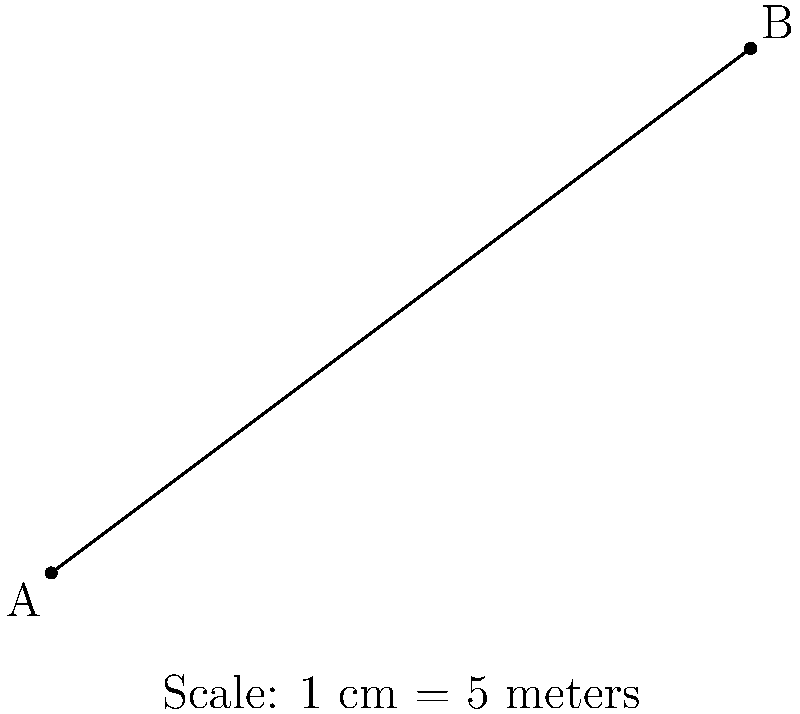In a scaled map of a crime scene, two key evidence points A and B are marked. If the distance between these points on the map is 10 cm and the scale of the map is 1 cm = 5 meters, what is the actual distance between the two points at the crime scene? To determine the actual distance between the two points, we need to follow these steps:

1. Understand the scale:
   The map scale is 1 cm = 5 meters

2. Identify the distance on the map:
   The distance between points A and B on the map is 10 cm

3. Set up the proportion:
   $1 \text{ cm on map} : 5 \text{ meters in reality} = 10 \text{ cm on map} : x \text{ meters in reality}$

4. Solve for x:
   $\frac{1}{5} = \frac{10}{x}$
   $x = 10 \times 5 = 50$

5. Interpret the result:
   The actual distance between points A and B at the crime scene is 50 meters.

This calculation is crucial for accurately reconstructing the crime scene and understanding the spatial relationships between key pieces of evidence, which is essential for a judge evaluating forensic testimony.
Answer: 50 meters 